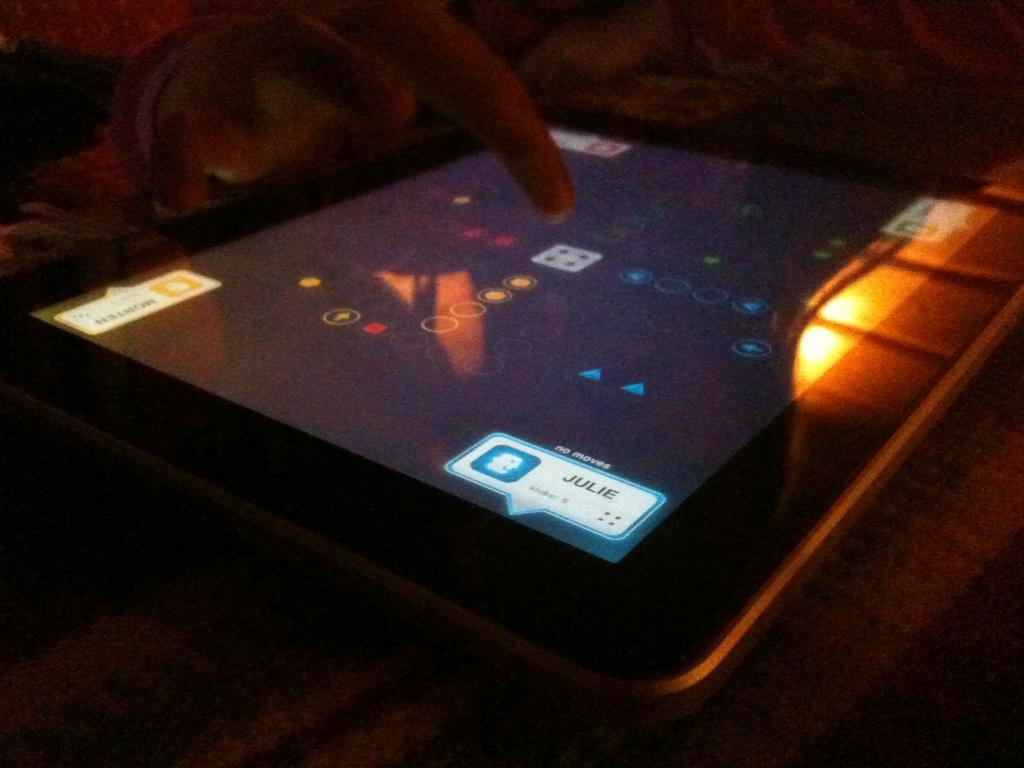What electronic device is visible in the image? There is a tablet in the image. What is the person in the image doing with the tablet? The person is playing a game on the tablet. Can you describe the lighting conditions in the image? The room appears to be dark. What type of pain is the person experiencing while playing the game on the tablet? There is no indication in the image that the person is experiencing any pain, so it cannot be determined from the picture. 